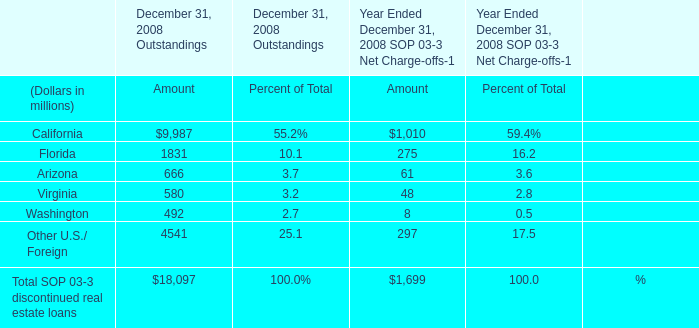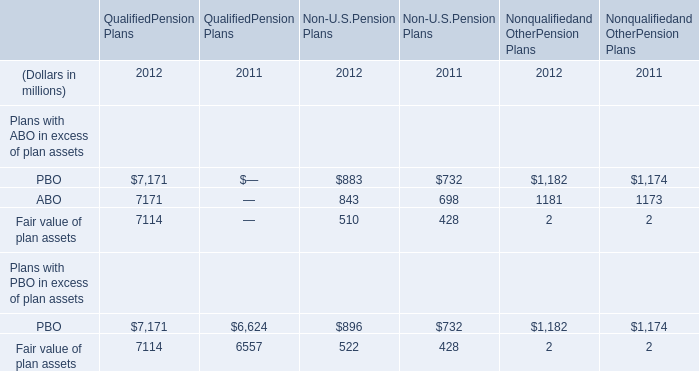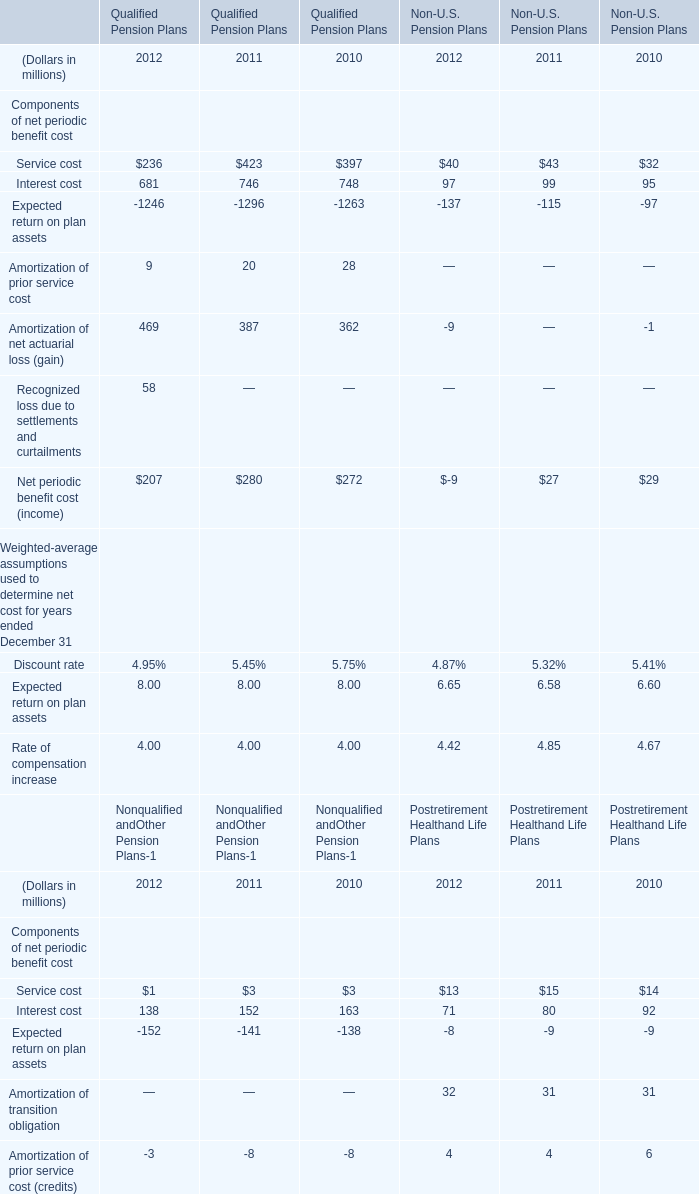In which year is Interest cost positive for Qualified Pension Plans? 
Answer: 2012 2011 2010. 